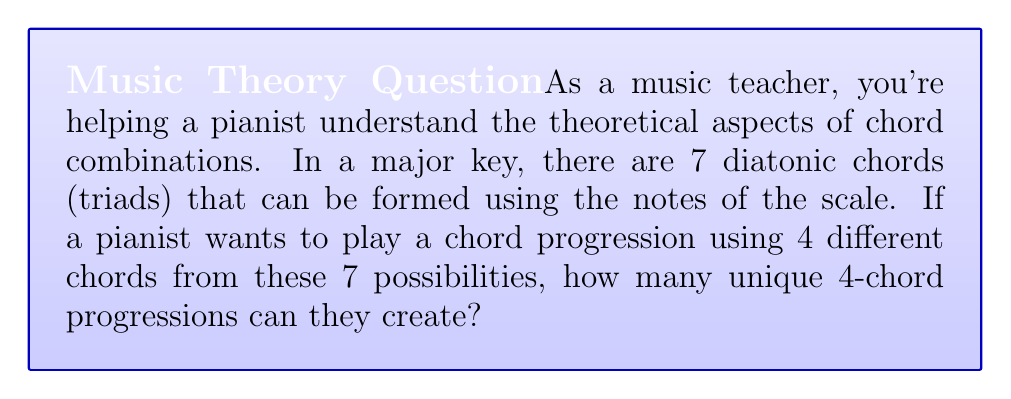Show me your answer to this math problem. To solve this problem, we need to use the concept of combinations from algebra. Here's how we approach it:

1) We have 7 chords to choose from, and we want to select 4 of them.

2) The order of selection doesn't matter (for example, C-F-G-Am is considered the same progression as F-C-Am-G). This means we're dealing with combinations, not permutations.

3) The formula for combinations is:

   $$C(n,r) = \frac{n!}{r!(n-r)!}$$

   Where $n$ is the total number of items to choose from, and $r$ is the number of items being chosen.

4) In this case, $n = 7$ (total chords) and $r = 4$ (chords in the progression).

5) Plugging these values into our formula:

   $$C(7,4) = \frac{7!}{4!(7-4)!} = \frac{7!}{4!3!}$$

6) Expanding this:
   
   $$\frac{7 \cdot 6 \cdot 5 \cdot 4!}{4! \cdot 3 \cdot 2 \cdot 1}$$

7) The $4!$ cancels out in the numerator and denominator:

   $$\frac{7 \cdot 6 \cdot 5}{3 \cdot 2 \cdot 1} = \frac{210}{6} = 35$$

Therefore, the pianist can create 35 unique 4-chord progressions using the 7 diatonic chords of a major key.
Answer: 35 unique 4-chord progressions 